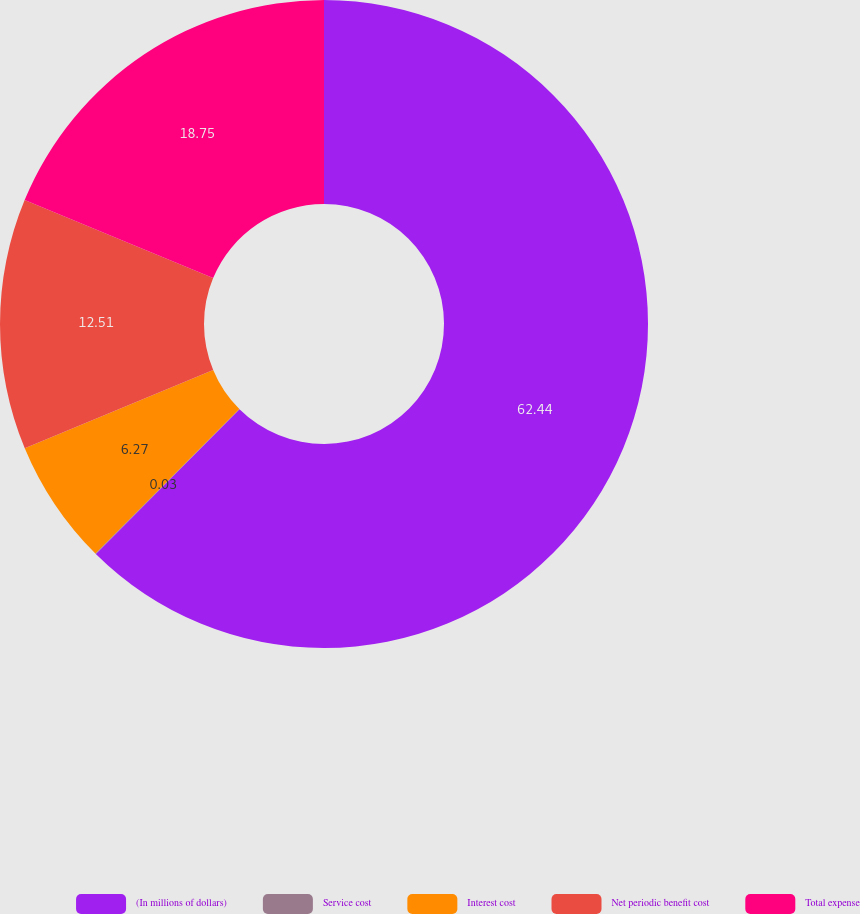Convert chart. <chart><loc_0><loc_0><loc_500><loc_500><pie_chart><fcel>(In millions of dollars)<fcel>Service cost<fcel>Interest cost<fcel>Net periodic benefit cost<fcel>Total expense<nl><fcel>62.43%<fcel>0.03%<fcel>6.27%<fcel>12.51%<fcel>18.75%<nl></chart> 